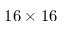Convert formula to latex. <formula><loc_0><loc_0><loc_500><loc_500>1 6 \times 1 6</formula> 